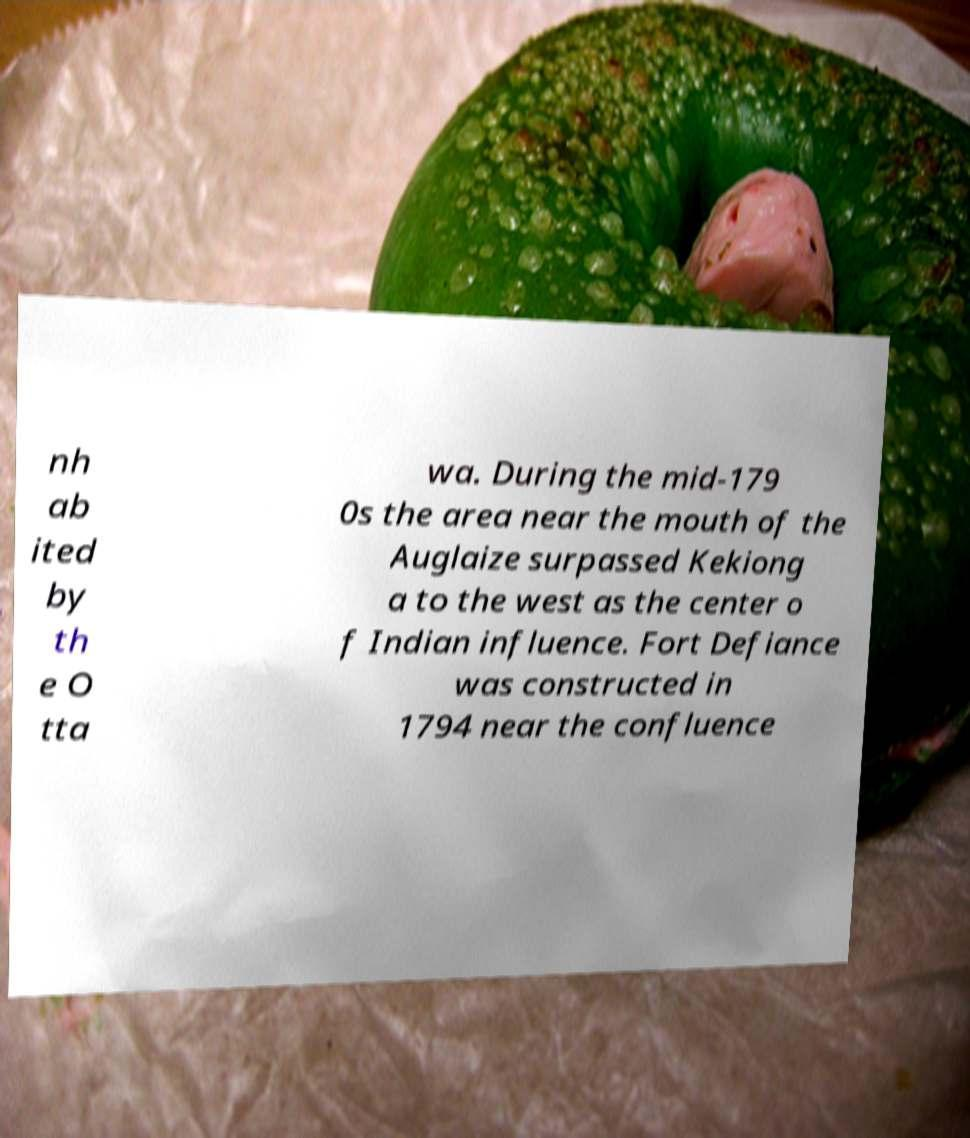Please read and relay the text visible in this image. What does it say? nh ab ited by th e O tta wa. During the mid-179 0s the area near the mouth of the Auglaize surpassed Kekiong a to the west as the center o f Indian influence. Fort Defiance was constructed in 1794 near the confluence 